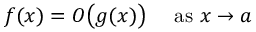Convert formula to latex. <formula><loc_0><loc_0><loc_500><loc_500>f ( x ) = O { \left ( } g ( x ) { \right ) } \quad a s x \to a</formula> 